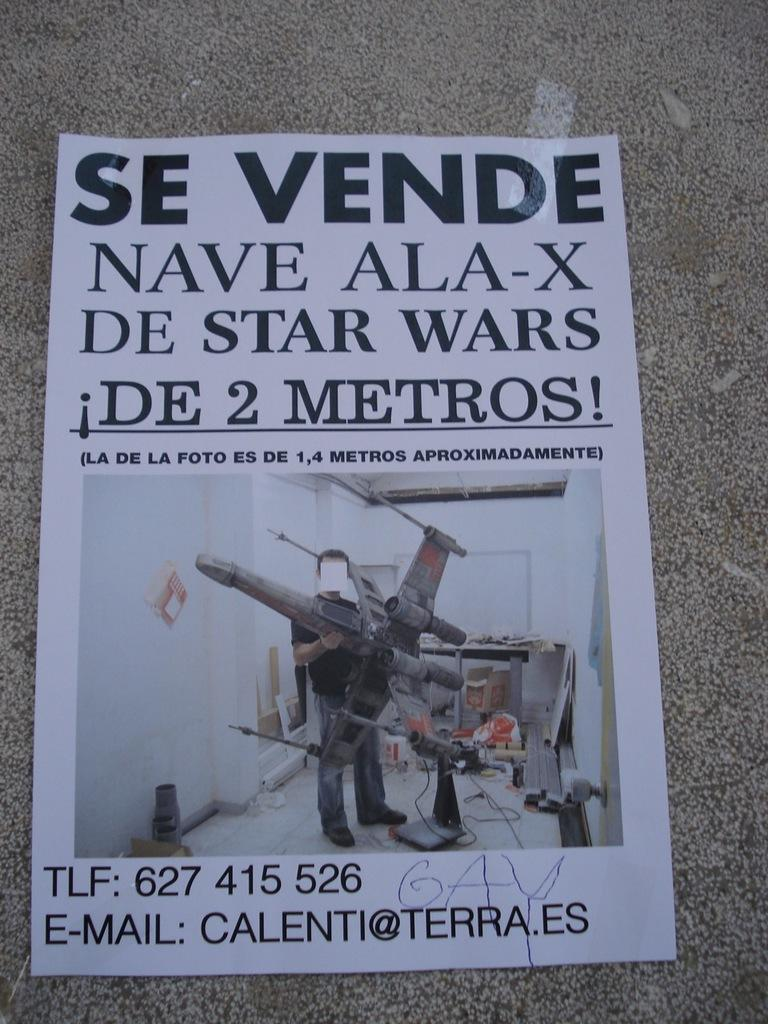<image>
Share a concise interpretation of the image provided. A flyer for large size Star Wars fighter wing models written in Spanish 